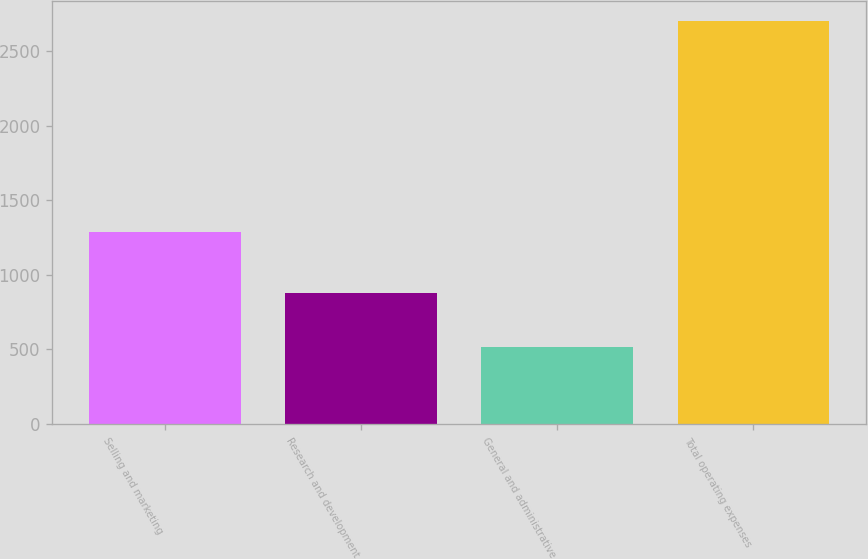Convert chart to OTSL. <chart><loc_0><loc_0><loc_500><loc_500><bar_chart><fcel>Selling and marketing<fcel>Research and development<fcel>General and administrative<fcel>Total operating expenses<nl><fcel>1289<fcel>881<fcel>518<fcel>2700<nl></chart> 